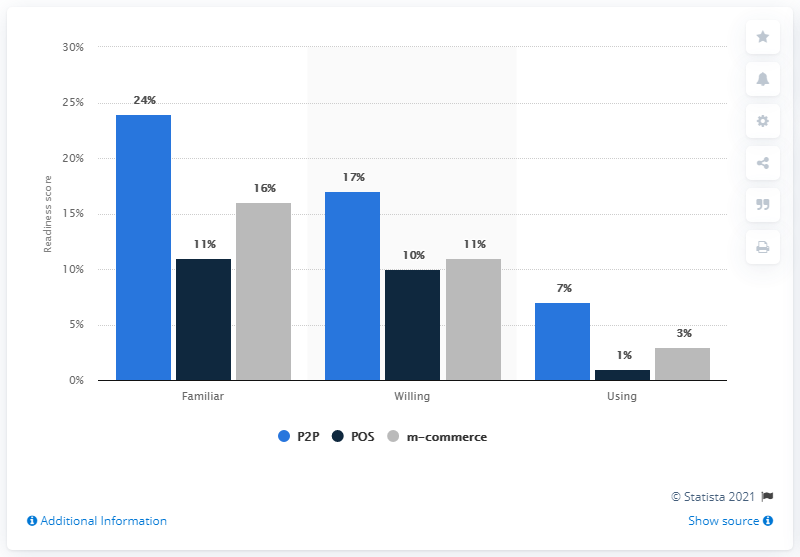List a handful of essential elements in this visual. The differences in readiness scores between P2P and POS are not always greater than 10% across all scenarios. The color navy blue is always the least. 